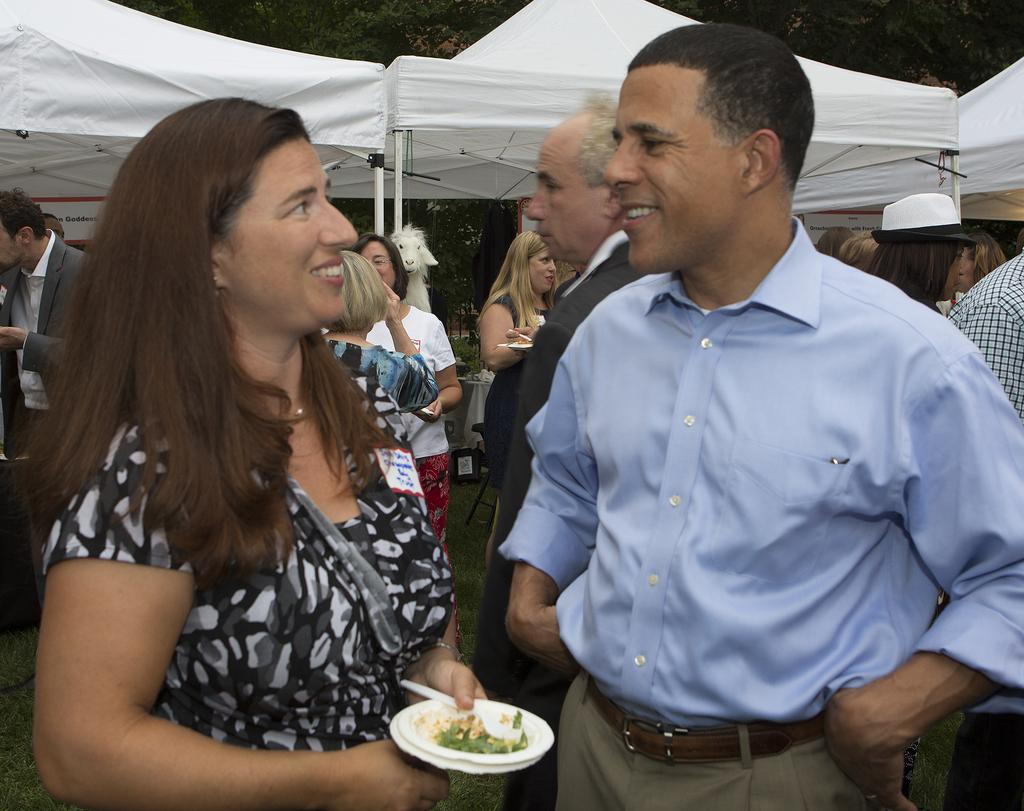What is the main subject of the image? The main subject of the image is a group of people. What are the people wearing in the image? The people are wearing clothes in the image. What can be seen in the background of the image? The people are standing beside tents in the image. Can you describe the person on the left side of the image? The person on the left side is holding a plate with her hand. Can you tell me how many rats are visible in the image? There are no rats present in the image. What type of trains can be seen in the image? There are no trains present in the image. 